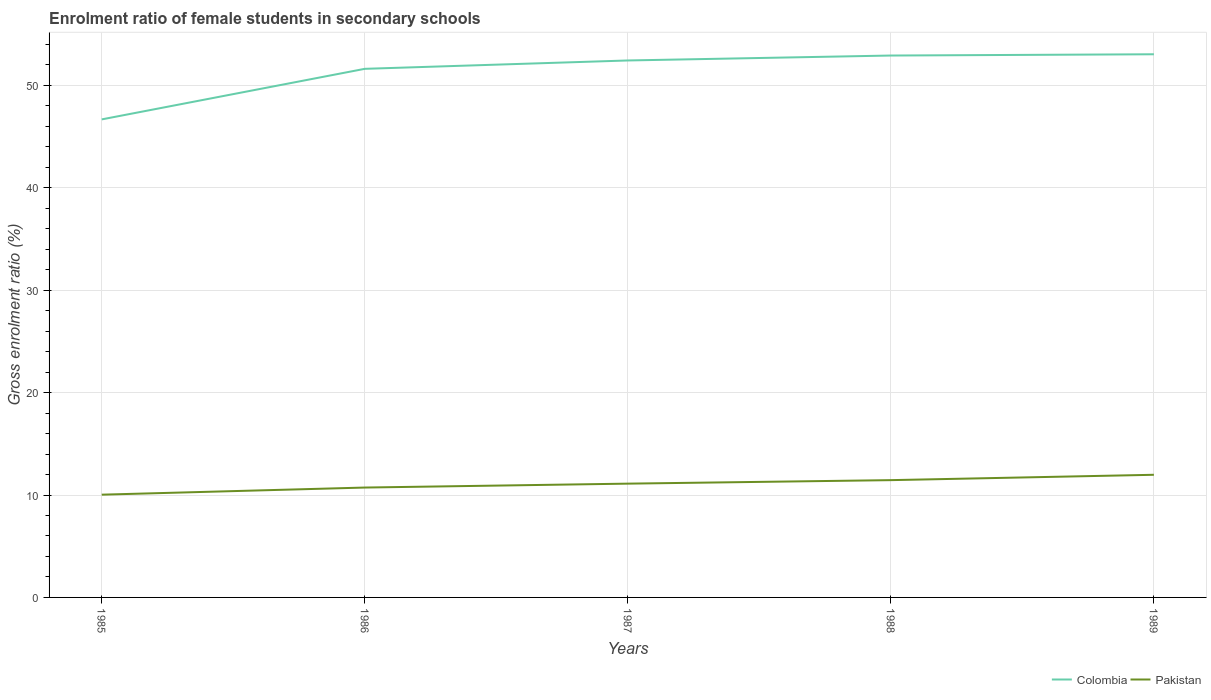How many different coloured lines are there?
Provide a succinct answer. 2. Is the number of lines equal to the number of legend labels?
Offer a very short reply. Yes. Across all years, what is the maximum enrolment ratio of female students in secondary schools in Pakistan?
Make the answer very short. 10.03. What is the total enrolment ratio of female students in secondary schools in Colombia in the graph?
Give a very brief answer. -6.36. What is the difference between the highest and the second highest enrolment ratio of female students in secondary schools in Pakistan?
Keep it short and to the point. 1.94. What is the difference between the highest and the lowest enrolment ratio of female students in secondary schools in Pakistan?
Keep it short and to the point. 3. Is the enrolment ratio of female students in secondary schools in Colombia strictly greater than the enrolment ratio of female students in secondary schools in Pakistan over the years?
Your answer should be very brief. No. How many lines are there?
Your answer should be compact. 2. Are the values on the major ticks of Y-axis written in scientific E-notation?
Your answer should be very brief. No. Does the graph contain any zero values?
Keep it short and to the point. No. What is the title of the graph?
Your answer should be compact. Enrolment ratio of female students in secondary schools. What is the label or title of the X-axis?
Make the answer very short. Years. What is the Gross enrolment ratio (%) of Colombia in 1985?
Offer a very short reply. 46.67. What is the Gross enrolment ratio (%) in Pakistan in 1985?
Provide a short and direct response. 10.03. What is the Gross enrolment ratio (%) of Colombia in 1986?
Your answer should be compact. 51.61. What is the Gross enrolment ratio (%) in Pakistan in 1986?
Offer a terse response. 10.73. What is the Gross enrolment ratio (%) of Colombia in 1987?
Your answer should be very brief. 52.43. What is the Gross enrolment ratio (%) in Pakistan in 1987?
Provide a succinct answer. 11.11. What is the Gross enrolment ratio (%) of Colombia in 1988?
Provide a succinct answer. 52.91. What is the Gross enrolment ratio (%) of Pakistan in 1988?
Keep it short and to the point. 11.45. What is the Gross enrolment ratio (%) of Colombia in 1989?
Make the answer very short. 53.03. What is the Gross enrolment ratio (%) of Pakistan in 1989?
Your answer should be very brief. 11.97. Across all years, what is the maximum Gross enrolment ratio (%) in Colombia?
Your answer should be very brief. 53.03. Across all years, what is the maximum Gross enrolment ratio (%) of Pakistan?
Give a very brief answer. 11.97. Across all years, what is the minimum Gross enrolment ratio (%) in Colombia?
Give a very brief answer. 46.67. Across all years, what is the minimum Gross enrolment ratio (%) of Pakistan?
Your response must be concise. 10.03. What is the total Gross enrolment ratio (%) of Colombia in the graph?
Your answer should be compact. 256.65. What is the total Gross enrolment ratio (%) in Pakistan in the graph?
Your answer should be compact. 55.3. What is the difference between the Gross enrolment ratio (%) in Colombia in 1985 and that in 1986?
Your answer should be very brief. -4.94. What is the difference between the Gross enrolment ratio (%) of Pakistan in 1985 and that in 1986?
Keep it short and to the point. -0.69. What is the difference between the Gross enrolment ratio (%) of Colombia in 1985 and that in 1987?
Your response must be concise. -5.75. What is the difference between the Gross enrolment ratio (%) of Pakistan in 1985 and that in 1987?
Offer a terse response. -1.08. What is the difference between the Gross enrolment ratio (%) in Colombia in 1985 and that in 1988?
Give a very brief answer. -6.24. What is the difference between the Gross enrolment ratio (%) in Pakistan in 1985 and that in 1988?
Your answer should be compact. -1.42. What is the difference between the Gross enrolment ratio (%) of Colombia in 1985 and that in 1989?
Provide a short and direct response. -6.36. What is the difference between the Gross enrolment ratio (%) of Pakistan in 1985 and that in 1989?
Give a very brief answer. -1.94. What is the difference between the Gross enrolment ratio (%) of Colombia in 1986 and that in 1987?
Provide a short and direct response. -0.82. What is the difference between the Gross enrolment ratio (%) in Pakistan in 1986 and that in 1987?
Your answer should be very brief. -0.38. What is the difference between the Gross enrolment ratio (%) in Colombia in 1986 and that in 1988?
Make the answer very short. -1.3. What is the difference between the Gross enrolment ratio (%) in Pakistan in 1986 and that in 1988?
Your answer should be compact. -0.72. What is the difference between the Gross enrolment ratio (%) in Colombia in 1986 and that in 1989?
Provide a succinct answer. -1.42. What is the difference between the Gross enrolment ratio (%) of Pakistan in 1986 and that in 1989?
Your answer should be compact. -1.25. What is the difference between the Gross enrolment ratio (%) of Colombia in 1987 and that in 1988?
Ensure brevity in your answer.  -0.48. What is the difference between the Gross enrolment ratio (%) of Pakistan in 1987 and that in 1988?
Give a very brief answer. -0.34. What is the difference between the Gross enrolment ratio (%) of Colombia in 1987 and that in 1989?
Make the answer very short. -0.6. What is the difference between the Gross enrolment ratio (%) in Pakistan in 1987 and that in 1989?
Keep it short and to the point. -0.86. What is the difference between the Gross enrolment ratio (%) in Colombia in 1988 and that in 1989?
Keep it short and to the point. -0.12. What is the difference between the Gross enrolment ratio (%) of Pakistan in 1988 and that in 1989?
Your answer should be compact. -0.52. What is the difference between the Gross enrolment ratio (%) of Colombia in 1985 and the Gross enrolment ratio (%) of Pakistan in 1986?
Ensure brevity in your answer.  35.95. What is the difference between the Gross enrolment ratio (%) in Colombia in 1985 and the Gross enrolment ratio (%) in Pakistan in 1987?
Provide a short and direct response. 35.56. What is the difference between the Gross enrolment ratio (%) of Colombia in 1985 and the Gross enrolment ratio (%) of Pakistan in 1988?
Your answer should be compact. 35.22. What is the difference between the Gross enrolment ratio (%) in Colombia in 1985 and the Gross enrolment ratio (%) in Pakistan in 1989?
Provide a short and direct response. 34.7. What is the difference between the Gross enrolment ratio (%) of Colombia in 1986 and the Gross enrolment ratio (%) of Pakistan in 1987?
Your answer should be compact. 40.5. What is the difference between the Gross enrolment ratio (%) in Colombia in 1986 and the Gross enrolment ratio (%) in Pakistan in 1988?
Offer a very short reply. 40.16. What is the difference between the Gross enrolment ratio (%) in Colombia in 1986 and the Gross enrolment ratio (%) in Pakistan in 1989?
Your response must be concise. 39.64. What is the difference between the Gross enrolment ratio (%) of Colombia in 1987 and the Gross enrolment ratio (%) of Pakistan in 1988?
Your answer should be compact. 40.97. What is the difference between the Gross enrolment ratio (%) of Colombia in 1987 and the Gross enrolment ratio (%) of Pakistan in 1989?
Provide a succinct answer. 40.45. What is the difference between the Gross enrolment ratio (%) in Colombia in 1988 and the Gross enrolment ratio (%) in Pakistan in 1989?
Provide a short and direct response. 40.93. What is the average Gross enrolment ratio (%) in Colombia per year?
Make the answer very short. 51.33. What is the average Gross enrolment ratio (%) in Pakistan per year?
Provide a short and direct response. 11.06. In the year 1985, what is the difference between the Gross enrolment ratio (%) in Colombia and Gross enrolment ratio (%) in Pakistan?
Keep it short and to the point. 36.64. In the year 1986, what is the difference between the Gross enrolment ratio (%) in Colombia and Gross enrolment ratio (%) in Pakistan?
Your answer should be very brief. 40.88. In the year 1987, what is the difference between the Gross enrolment ratio (%) of Colombia and Gross enrolment ratio (%) of Pakistan?
Provide a succinct answer. 41.32. In the year 1988, what is the difference between the Gross enrolment ratio (%) in Colombia and Gross enrolment ratio (%) in Pakistan?
Your answer should be compact. 41.46. In the year 1989, what is the difference between the Gross enrolment ratio (%) of Colombia and Gross enrolment ratio (%) of Pakistan?
Provide a short and direct response. 41.06. What is the ratio of the Gross enrolment ratio (%) in Colombia in 1985 to that in 1986?
Make the answer very short. 0.9. What is the ratio of the Gross enrolment ratio (%) in Pakistan in 1985 to that in 1986?
Make the answer very short. 0.94. What is the ratio of the Gross enrolment ratio (%) of Colombia in 1985 to that in 1987?
Offer a very short reply. 0.89. What is the ratio of the Gross enrolment ratio (%) of Pakistan in 1985 to that in 1987?
Keep it short and to the point. 0.9. What is the ratio of the Gross enrolment ratio (%) in Colombia in 1985 to that in 1988?
Offer a terse response. 0.88. What is the ratio of the Gross enrolment ratio (%) of Pakistan in 1985 to that in 1988?
Ensure brevity in your answer.  0.88. What is the ratio of the Gross enrolment ratio (%) of Colombia in 1985 to that in 1989?
Make the answer very short. 0.88. What is the ratio of the Gross enrolment ratio (%) in Pakistan in 1985 to that in 1989?
Give a very brief answer. 0.84. What is the ratio of the Gross enrolment ratio (%) of Colombia in 1986 to that in 1987?
Give a very brief answer. 0.98. What is the ratio of the Gross enrolment ratio (%) of Pakistan in 1986 to that in 1987?
Your answer should be very brief. 0.97. What is the ratio of the Gross enrolment ratio (%) in Colombia in 1986 to that in 1988?
Provide a succinct answer. 0.98. What is the ratio of the Gross enrolment ratio (%) of Pakistan in 1986 to that in 1988?
Your answer should be very brief. 0.94. What is the ratio of the Gross enrolment ratio (%) in Colombia in 1986 to that in 1989?
Keep it short and to the point. 0.97. What is the ratio of the Gross enrolment ratio (%) of Pakistan in 1986 to that in 1989?
Offer a terse response. 0.9. What is the ratio of the Gross enrolment ratio (%) in Colombia in 1987 to that in 1988?
Keep it short and to the point. 0.99. What is the ratio of the Gross enrolment ratio (%) in Pakistan in 1987 to that in 1988?
Your answer should be compact. 0.97. What is the ratio of the Gross enrolment ratio (%) of Pakistan in 1987 to that in 1989?
Provide a succinct answer. 0.93. What is the ratio of the Gross enrolment ratio (%) in Colombia in 1988 to that in 1989?
Make the answer very short. 1. What is the ratio of the Gross enrolment ratio (%) in Pakistan in 1988 to that in 1989?
Provide a succinct answer. 0.96. What is the difference between the highest and the second highest Gross enrolment ratio (%) in Colombia?
Give a very brief answer. 0.12. What is the difference between the highest and the second highest Gross enrolment ratio (%) in Pakistan?
Provide a succinct answer. 0.52. What is the difference between the highest and the lowest Gross enrolment ratio (%) in Colombia?
Give a very brief answer. 6.36. What is the difference between the highest and the lowest Gross enrolment ratio (%) in Pakistan?
Give a very brief answer. 1.94. 